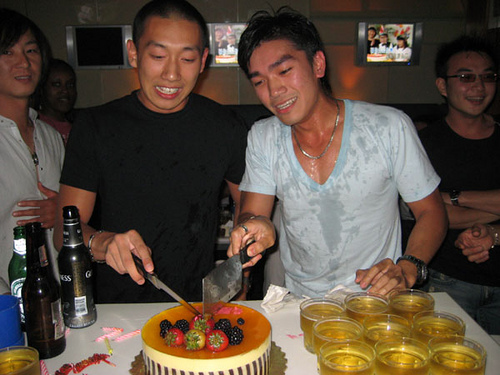How many people are visible in the picture? There are five people visible in the picture. What possibly happened before this moment? Before this moment, it is likely that the group was celebrating, possibly engaging in fun activities and preparing for the cake cutting ceremony. Describe the atmosphere in the picture. The atmosphere in the picture appears to be very lively and festive. There is a sense of joy and celebration among the group, with decorations, beverages, and a cake adding to the party mood. Imagine the cake is magical, what happens when it's cut? Upon cutting the magical cake, a burst of vibrant confetti flies out, and a shimmering aura blankets the room, making everyone feel joyous and enchanted. Sparkling lights flicker around the edges of the cake, making the moment even more magical and unforgettable. If you were to guess, what milestone could they be celebrating? Given the celebratory atmosphere and the birthday cake, it's plausible they could be celebrating a birthday milestone, such as a 30th birthday, or it might be an anniversary or a notable achievement. 